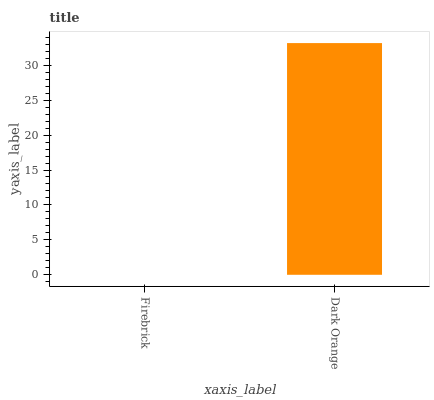Is Firebrick the minimum?
Answer yes or no. Yes. Is Dark Orange the maximum?
Answer yes or no. Yes. Is Dark Orange the minimum?
Answer yes or no. No. Is Dark Orange greater than Firebrick?
Answer yes or no. Yes. Is Firebrick less than Dark Orange?
Answer yes or no. Yes. Is Firebrick greater than Dark Orange?
Answer yes or no. No. Is Dark Orange less than Firebrick?
Answer yes or no. No. Is Dark Orange the high median?
Answer yes or no. Yes. Is Firebrick the low median?
Answer yes or no. Yes. Is Firebrick the high median?
Answer yes or no. No. Is Dark Orange the low median?
Answer yes or no. No. 